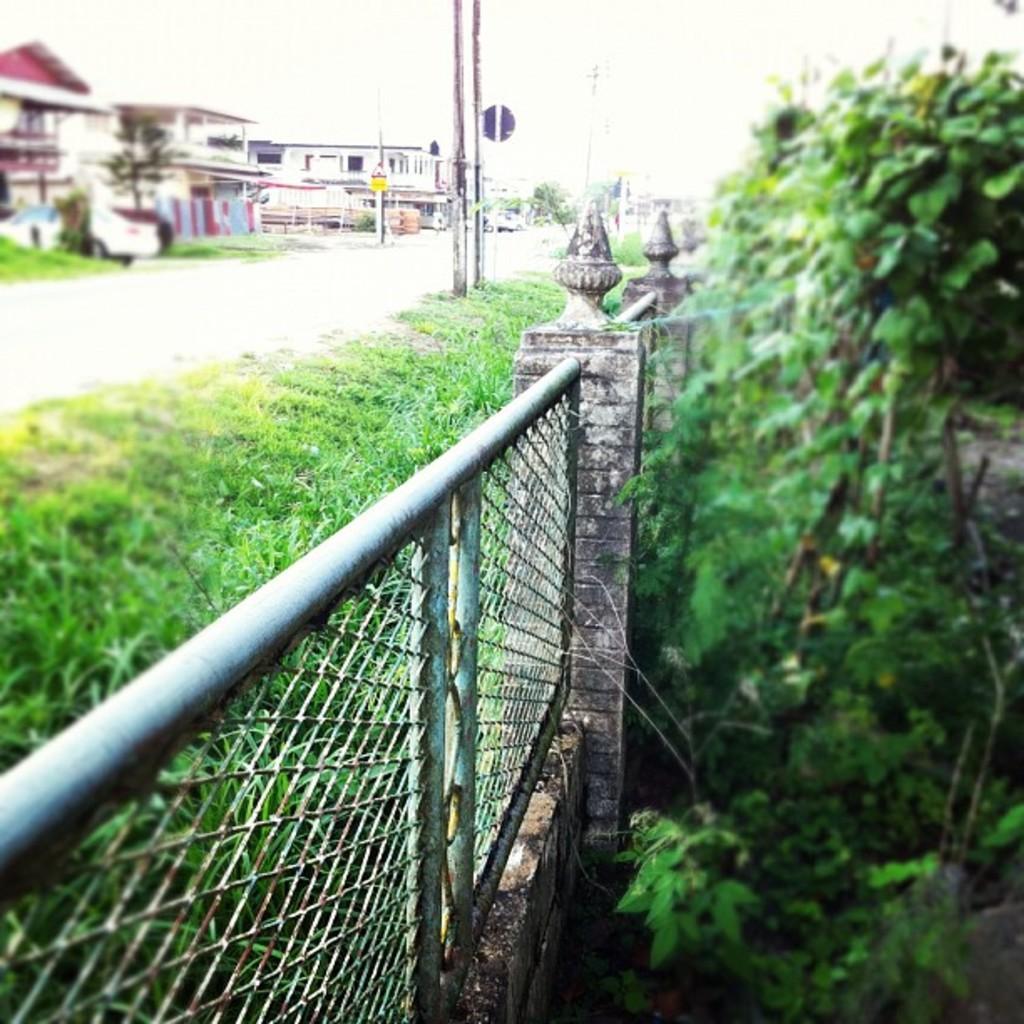Describe this image in one or two sentences. This is an outside view. At the bottom of the image there is a fencing. On the right side there are some plants. On the left side there is a road. On both sides of the road I can see the grass and poles. In the background there are some buildings. At the top of the image I can see the sky. 